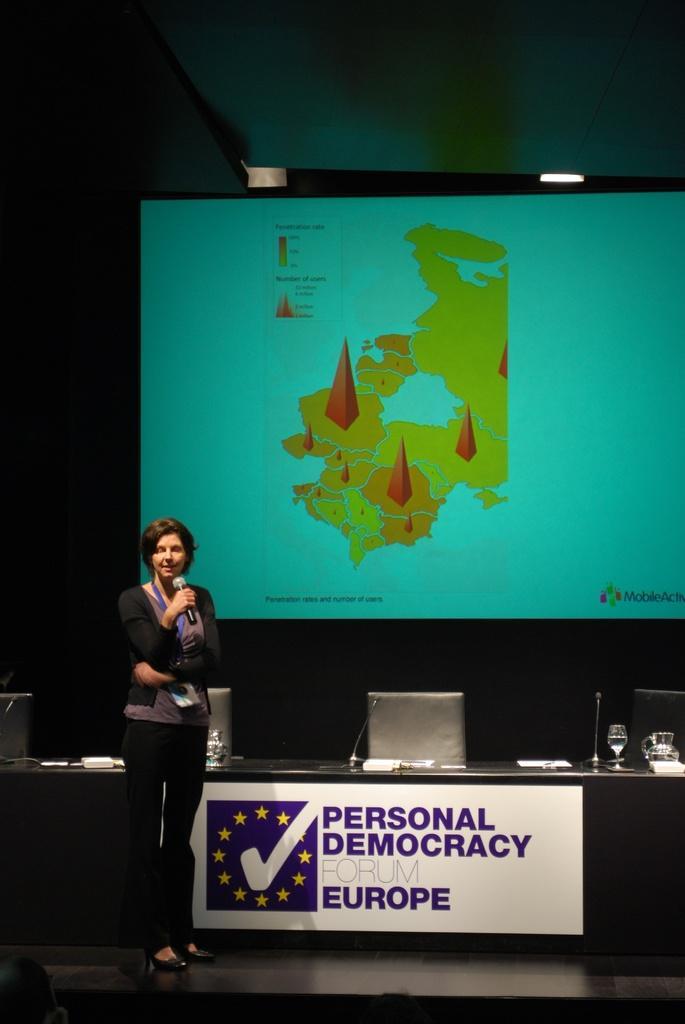Can you describe this image briefly? In this image, we can see a person holding a microphone is standing. We can see a table with some objects like glasses, microphones. We can see some chairs and the screen. We can also see the roof. 